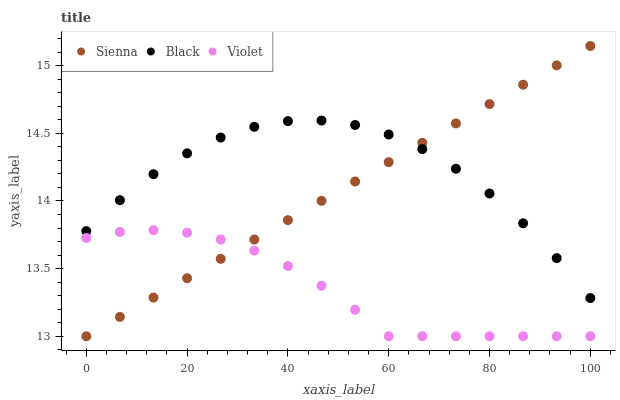Does Violet have the minimum area under the curve?
Answer yes or no. Yes. Does Black have the maximum area under the curve?
Answer yes or no. Yes. Does Black have the minimum area under the curve?
Answer yes or no. No. Does Violet have the maximum area under the curve?
Answer yes or no. No. Is Sienna the smoothest?
Answer yes or no. Yes. Is Black the roughest?
Answer yes or no. Yes. Is Violet the smoothest?
Answer yes or no. No. Is Violet the roughest?
Answer yes or no. No. Does Sienna have the lowest value?
Answer yes or no. Yes. Does Black have the lowest value?
Answer yes or no. No. Does Sienna have the highest value?
Answer yes or no. Yes. Does Black have the highest value?
Answer yes or no. No. Is Violet less than Black?
Answer yes or no. Yes. Is Black greater than Violet?
Answer yes or no. Yes. Does Sienna intersect Black?
Answer yes or no. Yes. Is Sienna less than Black?
Answer yes or no. No. Is Sienna greater than Black?
Answer yes or no. No. Does Violet intersect Black?
Answer yes or no. No. 